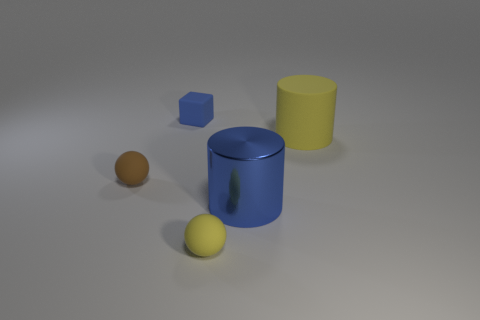What is the size of the yellow matte thing that is in front of the brown matte sphere?
Your response must be concise. Small. Is there any other thing that is made of the same material as the yellow sphere?
Give a very brief answer. Yes. What number of big red rubber cylinders are there?
Make the answer very short. 0. Does the small matte block have the same color as the big shiny cylinder?
Make the answer very short. Yes. There is a thing that is both in front of the large rubber thing and to the left of the tiny yellow thing; what color is it?
Provide a short and direct response. Brown. There is a small yellow thing; are there any yellow spheres right of it?
Your response must be concise. No. What number of brown balls are behind the big object that is behind the brown thing?
Ensure brevity in your answer.  0. What is the size of the brown thing that is made of the same material as the yellow cylinder?
Provide a succinct answer. Small. What is the size of the brown object?
Give a very brief answer. Small. Do the yellow sphere and the blue cylinder have the same material?
Make the answer very short. No. 